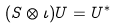<formula> <loc_0><loc_0><loc_500><loc_500>( S \otimes \iota ) U = U ^ { * }</formula> 